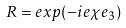<formula> <loc_0><loc_0><loc_500><loc_500>R = e x p ( - i e \chi e _ { 3 } )</formula> 